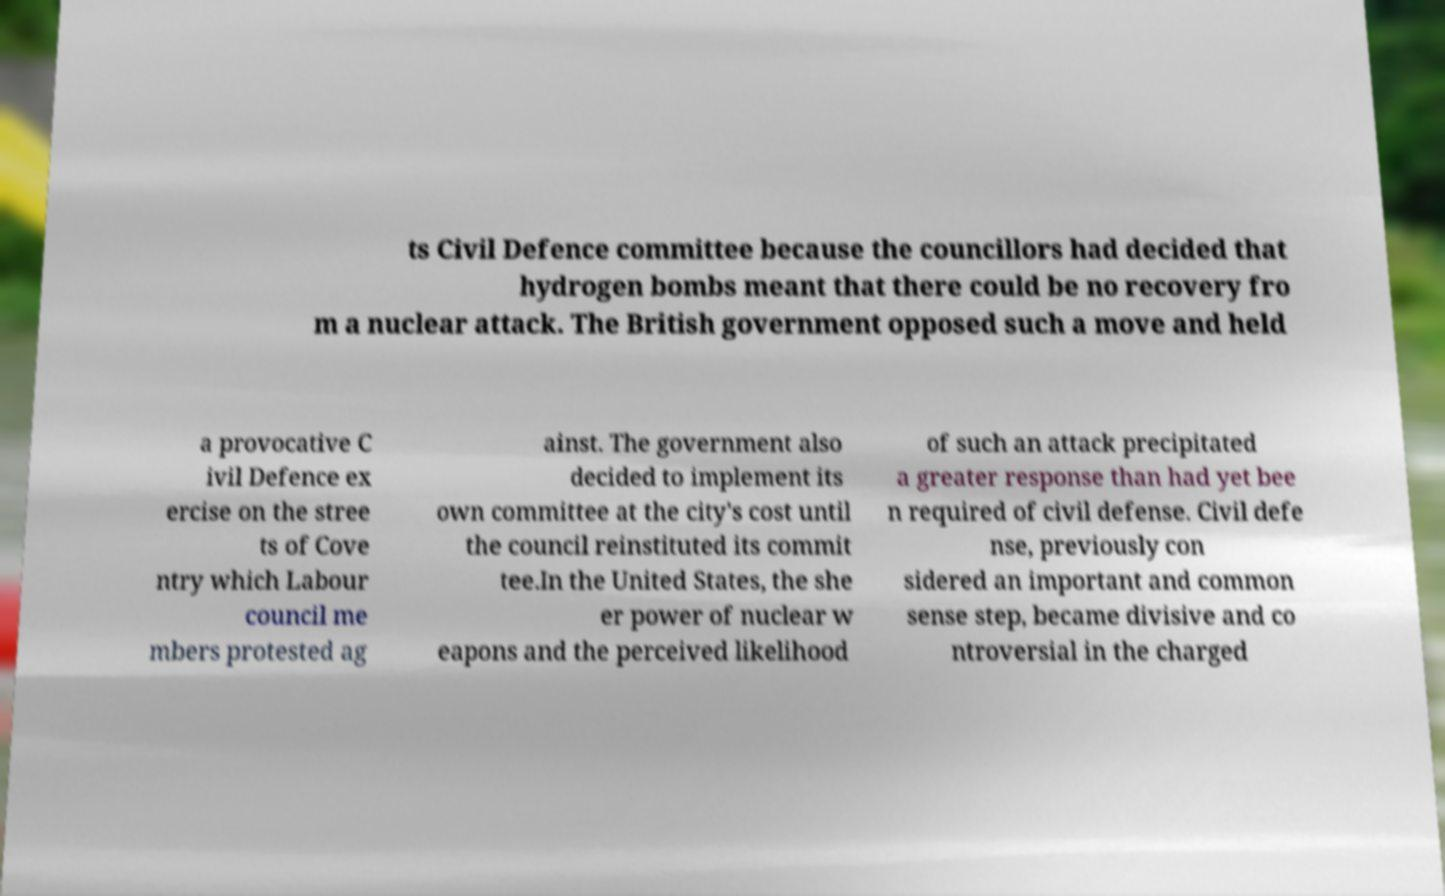Could you extract and type out the text from this image? ts Civil Defence committee because the councillors had decided that hydrogen bombs meant that there could be no recovery fro m a nuclear attack. The British government opposed such a move and held a provocative C ivil Defence ex ercise on the stree ts of Cove ntry which Labour council me mbers protested ag ainst. The government also decided to implement its own committee at the city's cost until the council reinstituted its commit tee.In the United States, the she er power of nuclear w eapons and the perceived likelihood of such an attack precipitated a greater response than had yet bee n required of civil defense. Civil defe nse, previously con sidered an important and common sense step, became divisive and co ntroversial in the charged 